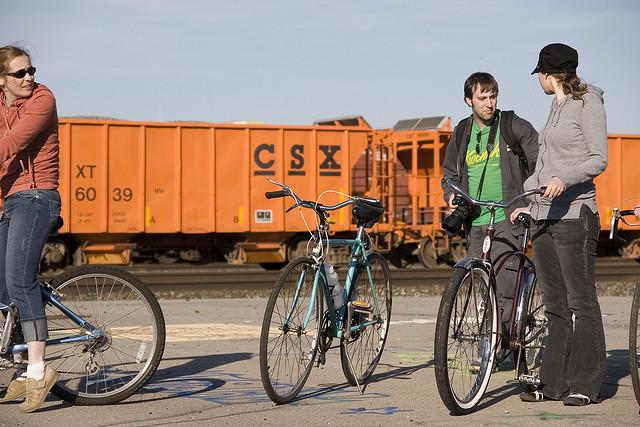What color is the bike on the right?
Concise answer only. Red. Does the color of the bike match the train?
Write a very short answer. No. Are they in a city?
Give a very brief answer. No. Does the woman's hat match her shirt?
Keep it brief. No. Is this photo taken in the United States?
Quick response, please. Yes. What color is her bike?
Answer briefly. Red. Is this lady carrying a bag?
Short answer required. No. Is it raining?
Concise answer only. No. What is behind the people?
Be succinct. Train. Is the kickstand down?
Write a very short answer. Yes. What are the letters on train boxcar?
Answer briefly. Csx. What color is the train?
Quick response, please. Orange. How many bikes?
Answer briefly. 3. 